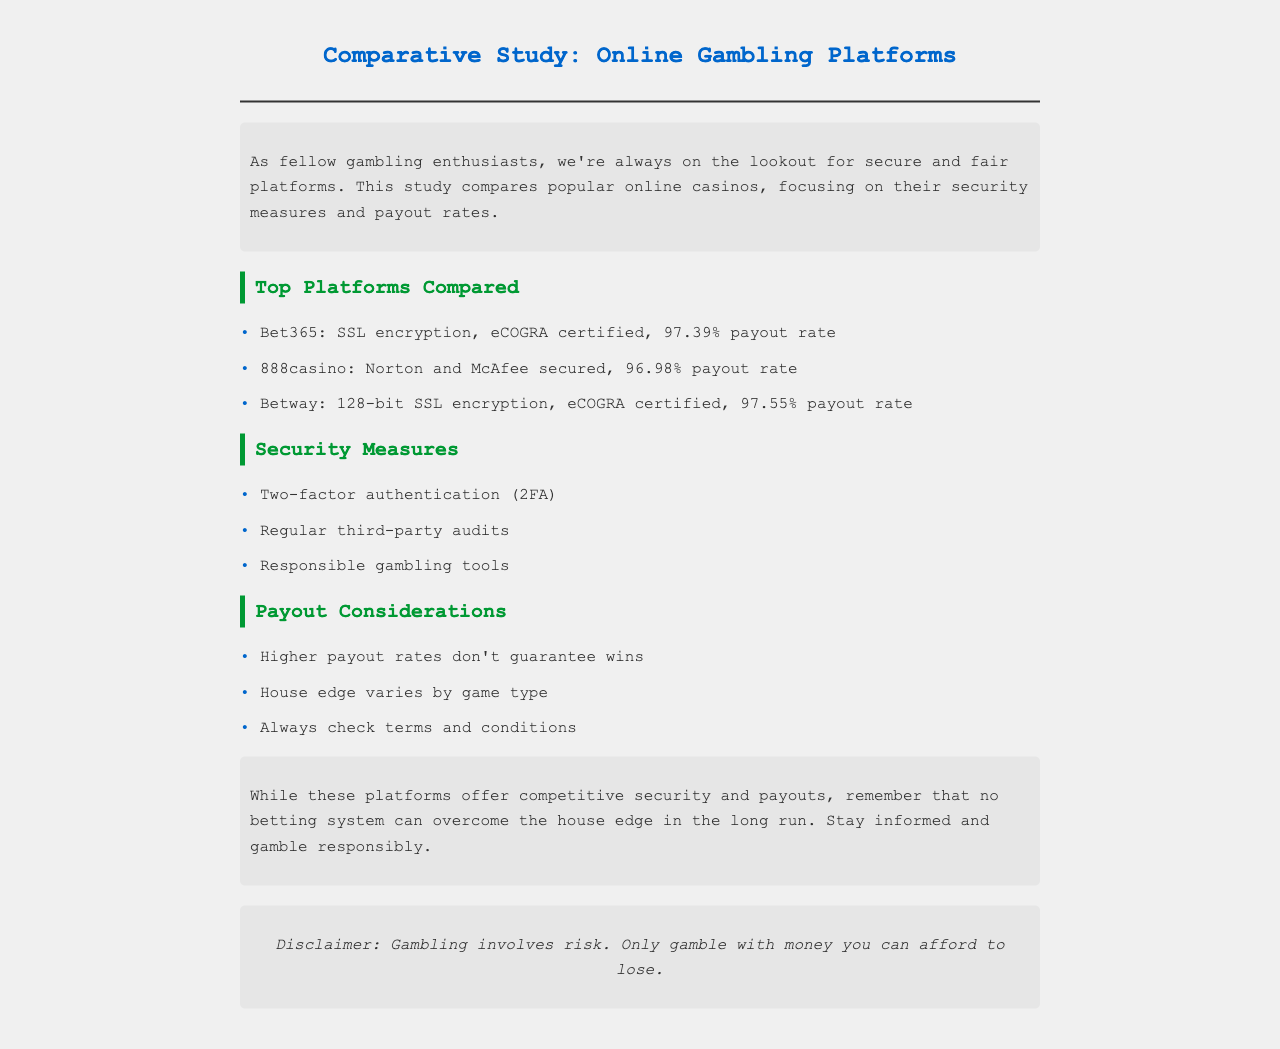what is the payout rate for Bet365? The payout rate for Bet365 is mentioned in the document, which states it as 97.39%.
Answer: 97.39% which security measure involves verifying identity through multiple steps? The document lists security measures and one of them is two-factor authentication, which involves verifying identity through multiple steps.
Answer: two-factor authentication what is the certification held by Betway? According to the document, Betway is eCOGRA certified, which is mentioned in its security measures.
Answer: eCOGRA certified what is the payout rate for 888casino? The document specifies that 888casino has a payout rate of 96.98%.
Answer: 96.98% which platform has the highest payout rate? The comparison in the document indicates that Betway has the highest payout rate of 97.55%.
Answer: 97.55% how often should you check the terms and conditions according to the document? The document advises to always check the terms and conditions, indicating a regular practice is important for users.
Answer: always what type of document is this? The document is identified as a comparative study, focused on online gambling platforms.
Answer: comparative study what is a key takeaway from the conclusion of the document? The conclusion emphasizes that no betting system can overcome the house edge in the long run.
Answer: house edge 